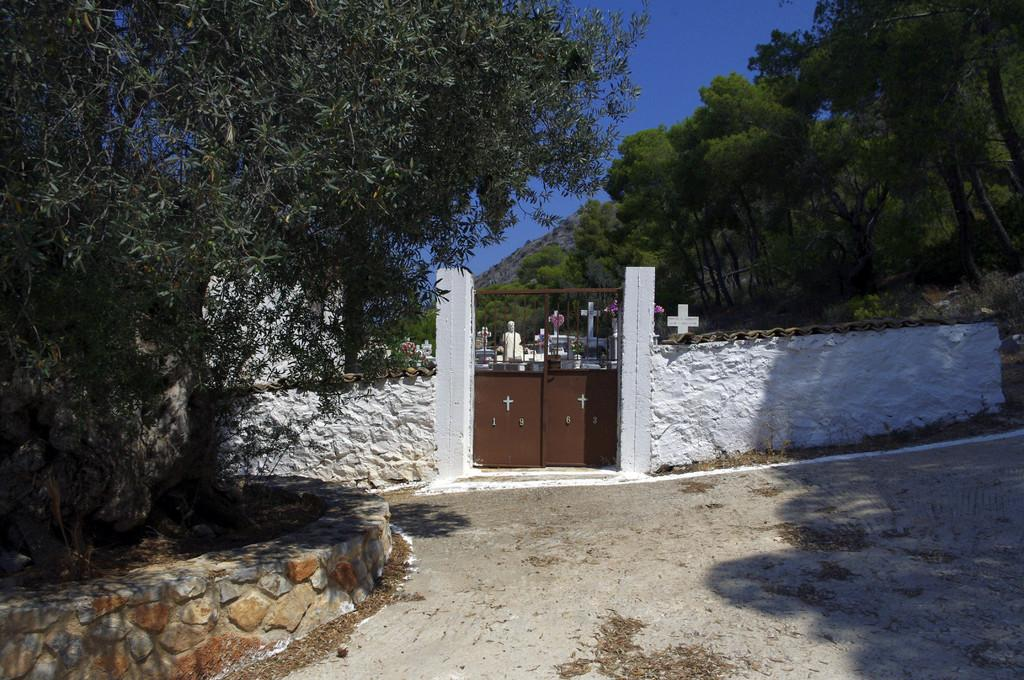What is the color of the compound in the image? The compound is white in color. What type of structure is the compound? The compound is a gate. What can be seen on the ground in the image? There is a footpath in the image. What type of barrier is present in the image? There is a stone wall in the image. What type of vegetation is present in the image? There are trees in the image. What symbol can be seen in the image? There is a cross symbol in the image. What type of artwork is present in the image? There is a sculpture in the image. What is the color of the sky in the image? The sky is blue in the image. How many yams are being held by the sculpture in the image? There is no yam present in the image, and the sculpture is not holding anything. 